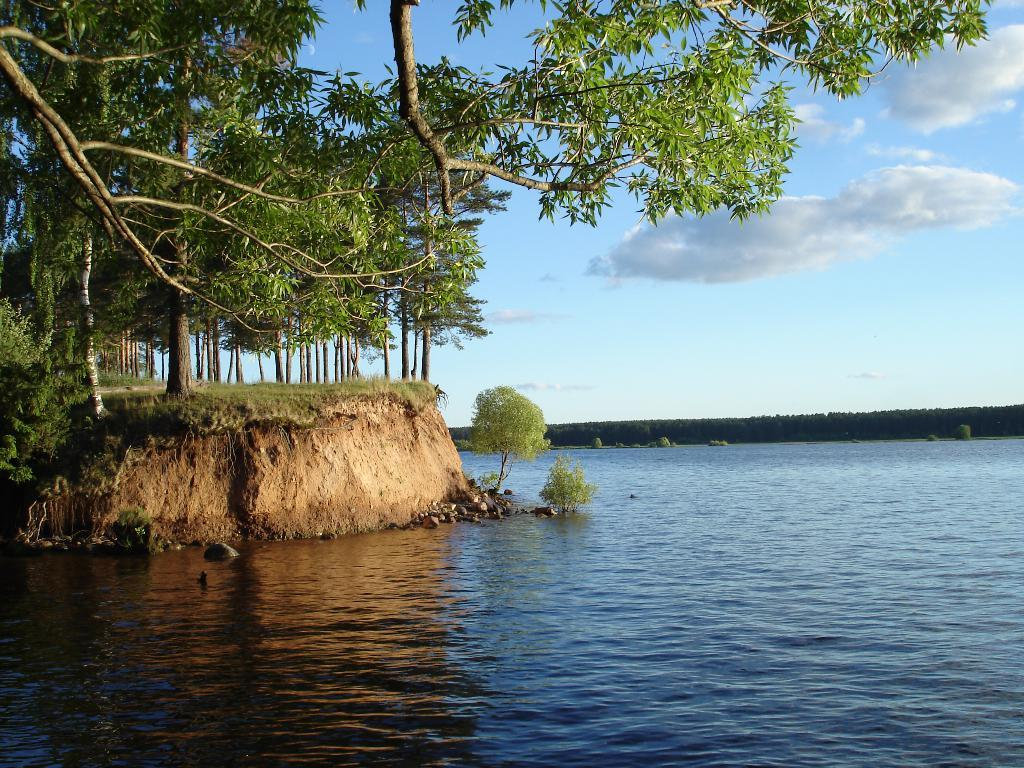What is the primary element visible in the image? There is water in the image. What types of vegetation can be seen in the image? There are plants and trees in the image. What part of the natural environment is visible in the image? The ground and sky are visible in the image. What type of haircut is the water receiving in the image? There is no haircut present in the image, as haircuts are not applicable to water. 